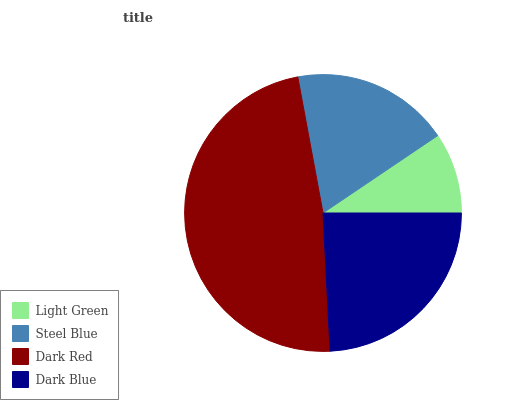Is Light Green the minimum?
Answer yes or no. Yes. Is Dark Red the maximum?
Answer yes or no. Yes. Is Steel Blue the minimum?
Answer yes or no. No. Is Steel Blue the maximum?
Answer yes or no. No. Is Steel Blue greater than Light Green?
Answer yes or no. Yes. Is Light Green less than Steel Blue?
Answer yes or no. Yes. Is Light Green greater than Steel Blue?
Answer yes or no. No. Is Steel Blue less than Light Green?
Answer yes or no. No. Is Dark Blue the high median?
Answer yes or no. Yes. Is Steel Blue the low median?
Answer yes or no. Yes. Is Light Green the high median?
Answer yes or no. No. Is Light Green the low median?
Answer yes or no. No. 